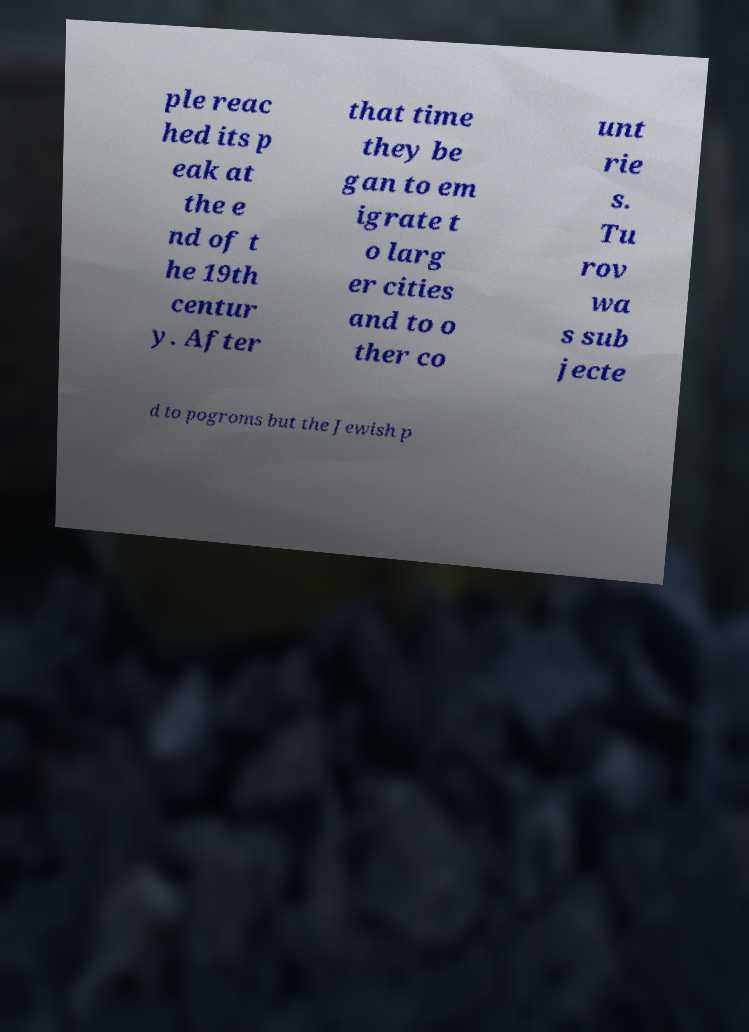I need the written content from this picture converted into text. Can you do that? ple reac hed its p eak at the e nd of t he 19th centur y. After that time they be gan to em igrate t o larg er cities and to o ther co unt rie s. Tu rov wa s sub jecte d to pogroms but the Jewish p 